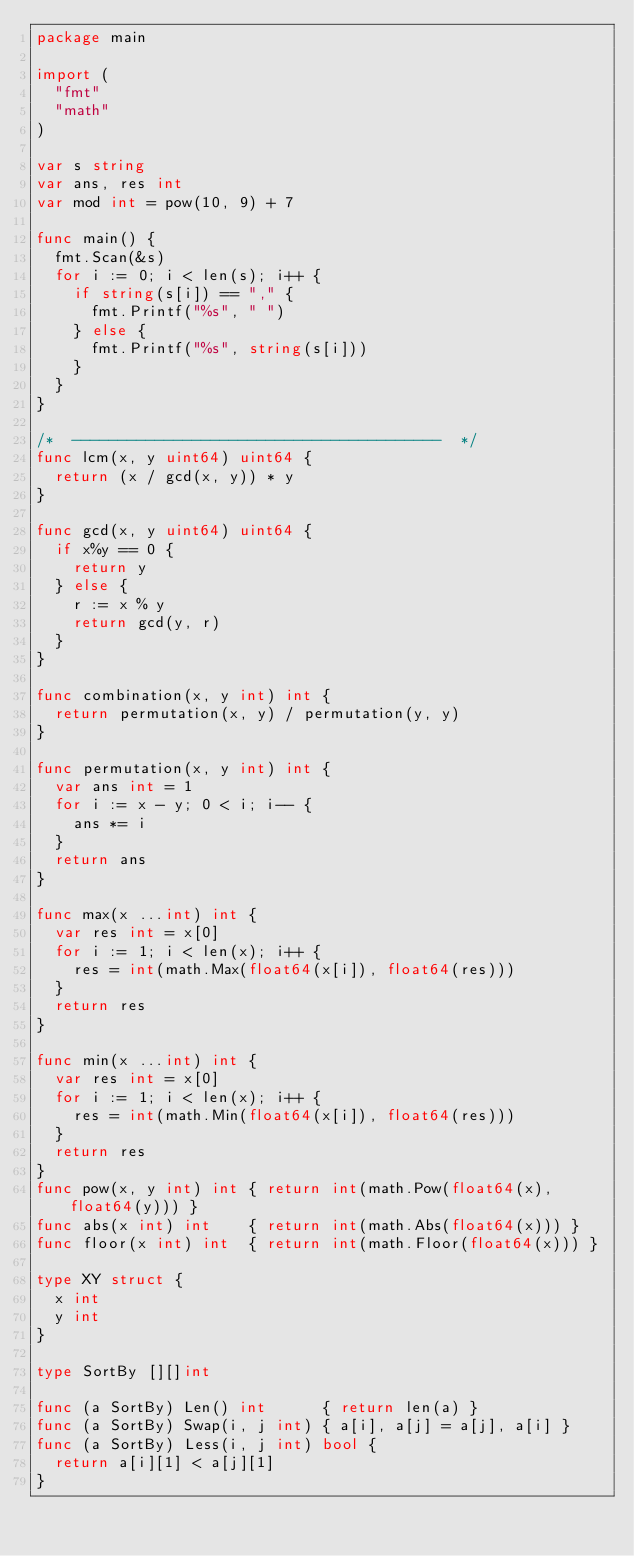Convert code to text. <code><loc_0><loc_0><loc_500><loc_500><_Go_>package main

import (
	"fmt"
	"math"
)

var s string
var ans, res int
var mod int = pow(10, 9) + 7

func main() {
	fmt.Scan(&s)
	for i := 0; i < len(s); i++ {
		if string(s[i]) == "," {
			fmt.Printf("%s", " ")
		} else {
			fmt.Printf("%s", string(s[i]))
		}
	}
}

/*  ----------------------------------------  */
func lcm(x, y uint64) uint64 {
	return (x / gcd(x, y)) * y
}

func gcd(x, y uint64) uint64 {
	if x%y == 0 {
		return y
	} else {
		r := x % y
		return gcd(y, r)
	}
}

func combination(x, y int) int {
	return permutation(x, y) / permutation(y, y)
}

func permutation(x, y int) int {
	var ans int = 1
	for i := x - y; 0 < i; i-- {
		ans *= i
	}
	return ans
}

func max(x ...int) int {
	var res int = x[0]
	for i := 1; i < len(x); i++ {
		res = int(math.Max(float64(x[i]), float64(res)))
	}
	return res
}

func min(x ...int) int {
	var res int = x[0]
	for i := 1; i < len(x); i++ {
		res = int(math.Min(float64(x[i]), float64(res)))
	}
	return res
}
func pow(x, y int) int { return int(math.Pow(float64(x), float64(y))) }
func abs(x int) int    { return int(math.Abs(float64(x))) }
func floor(x int) int  { return int(math.Floor(float64(x))) }

type XY struct {
	x int
	y int
}

type SortBy [][]int

func (a SortBy) Len() int      { return len(a) }
func (a SortBy) Swap(i, j int) { a[i], a[j] = a[j], a[i] }
func (a SortBy) Less(i, j int) bool {
	return a[i][1] < a[j][1]
}
</code> 